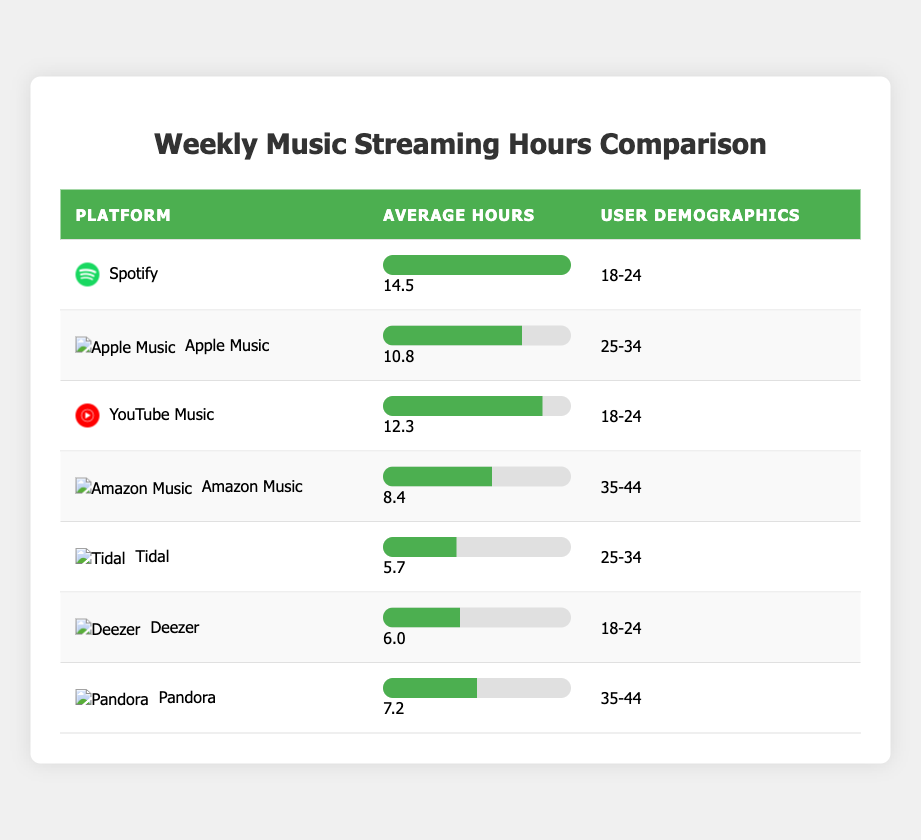What is the average number of streaming hours for Spotify? From the table, it states that Spotify has an average of 14.5 hours. So, the answer is directly taken from the row for Spotify.
Answer: 14.5 Which platform has the lowest average streaming hours? By looking through the table, Amazon Music has the lowest average hours at 8.4. This is the smallest value compared to others listed.
Answer: Amazon Music Is it true that Tidal has more average hours than Deezer? Tidal has an average of 5.7 hours while Deezer has 6.0 hours. Since 5.7 is less than 6.0, the statement is false.
Answer: No What is the average number of streaming hours for platforms used by users aged 18-24? The platforms for 18-24 users are Spotify (14.5), YouTube Music (12.3), and Deezer (6.0). Summing those gives 14.5 + 12.3 + 6.0 = 32.8. The average for these three is 32.8 / 3 = 10.93.
Answer: 10.93 Which demographic uses Apple Music, and how many hours do they stream on average? The table shows that Apple Music has a user demographic of 25-34 and an average of 10.8 hours of streaming. This information can be directly retrieved from the Apple Music row.
Answer: 25-34, 10.8 What is the combined average streaming hours for users aged 35-44 on Amazon Music and Pandora? For Amazon Music, the average is 8.4 hours, and for Pandora, it is 7.2 hours. Adding them gives 8.4 + 7.2 = 15.6. The combined average for both platforms is 15.6 / 2 = 7.8.
Answer: 7.8 Which platform has a higher average, YouTube Music or Apple Music? YouTube Music has an average of 12.3 hours, and Apple Music has 10.8 hours. Since 12.3 is greater than 10.8, YouTube Music has a higher average.
Answer: YouTube Music How many platforms have an average of more than 10 hours? By identifying the platforms: Spotify (14.5), YouTube Music (12.3), and Apple Music (10.8) all have more than 10 hours. There are three platforms that meet this criterion.
Answer: 3 